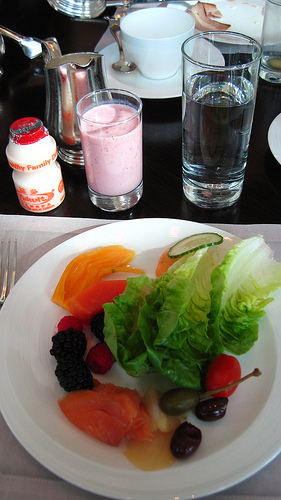<image>
Can you confirm if the fork is on the plate? No. The fork is not positioned on the plate. They may be near each other, but the fork is not supported by or resting on top of the plate. Where is the spoon in relation to the teacup? Is it in the teacup? No. The spoon is not contained within the teacup. These objects have a different spatial relationship. Is the salad in front of the glass? Yes. The salad is positioned in front of the glass, appearing closer to the camera viewpoint. 